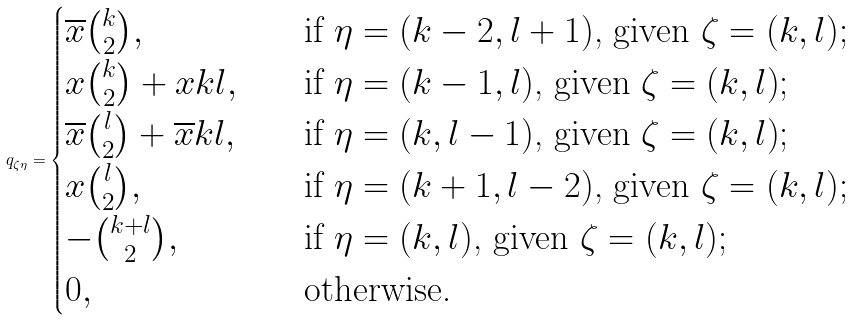<formula> <loc_0><loc_0><loc_500><loc_500>q _ { \zeta \eta } = \begin{cases} \overline { x } \binom { k } { 2 } , \quad & \text {if $\eta=(k-2,l+1)$, given $\zeta =(k,l)$} ; \\ x \binom { k } { 2 } + x k l , \quad & \text {if $\eta =(k-1,l)$, given $\zeta =(k,l)$} ; \\ \overline { x } \binom { l } { 2 } + \overline { x } k l , \quad & \text {if $\eta =(k,l-1)$, given $\zeta =(k,l)$} ; \\ x \binom { l } { 2 } , \quad & \text {if $\eta =(k+1,l-2)$, given $\zeta=(k,l)$} ; \\ - \binom { k + l } { 2 } , \quad & \text {if $\eta =(k,l)$, given $\zeta =(k,l)$} ; \\ 0 , & \text {otherwise.} \end{cases}</formula> 